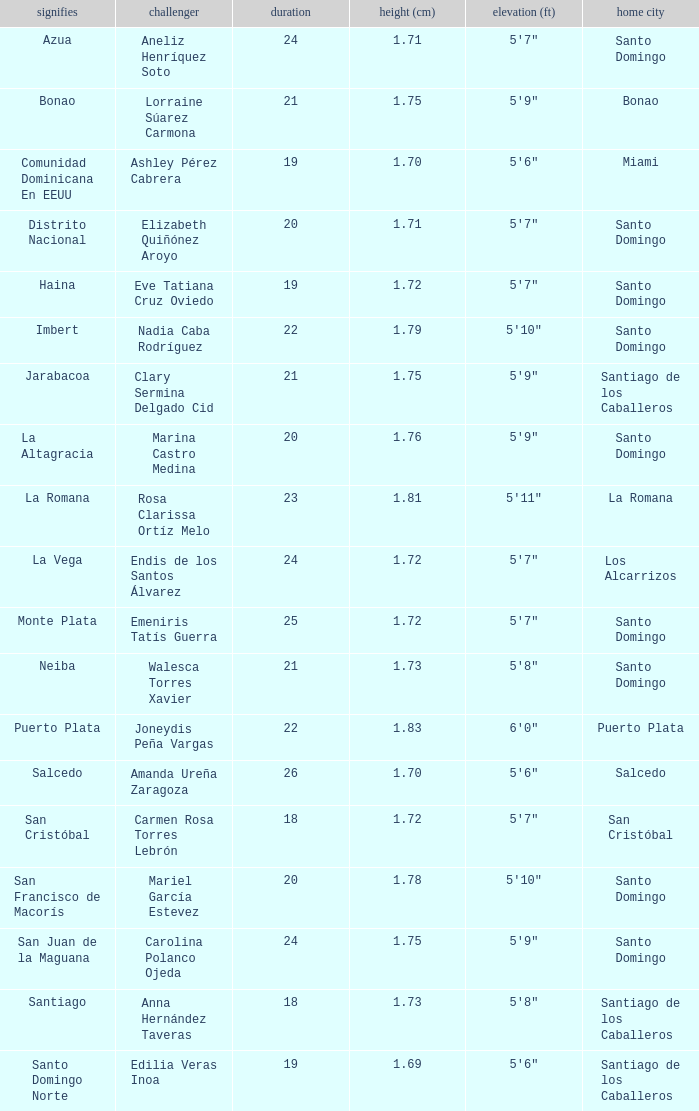Name the most age 26.0. 